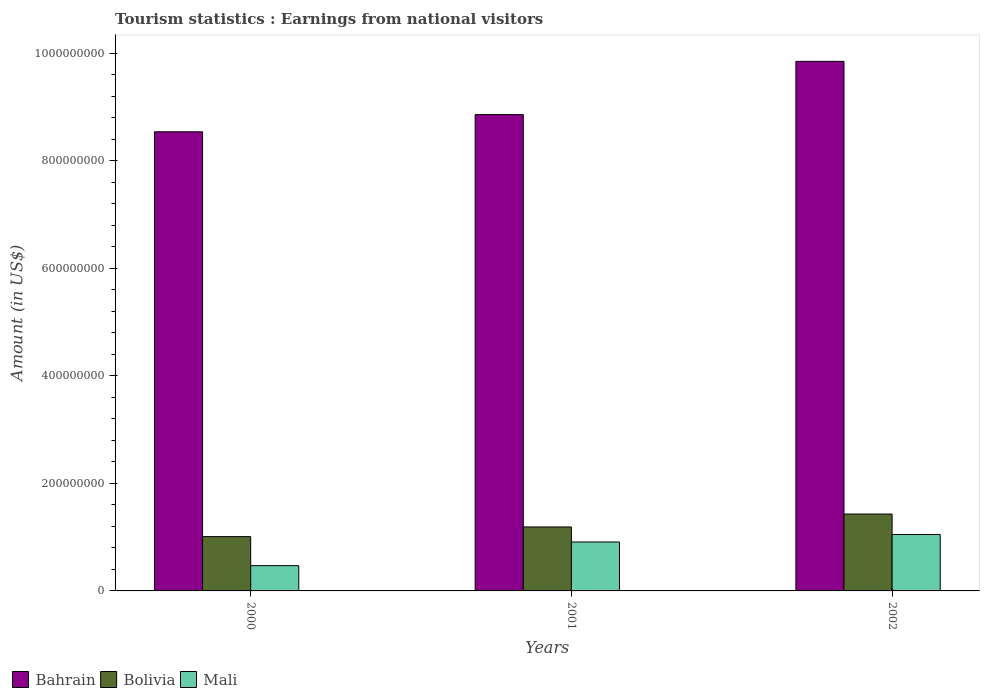How many different coloured bars are there?
Provide a short and direct response. 3. How many groups of bars are there?
Your response must be concise. 3. Are the number of bars per tick equal to the number of legend labels?
Keep it short and to the point. Yes. Are the number of bars on each tick of the X-axis equal?
Your response must be concise. Yes. What is the label of the 2nd group of bars from the left?
Make the answer very short. 2001. What is the earnings from national visitors in Bahrain in 2002?
Provide a succinct answer. 9.85e+08. Across all years, what is the maximum earnings from national visitors in Bolivia?
Your answer should be compact. 1.43e+08. Across all years, what is the minimum earnings from national visitors in Bahrain?
Your answer should be very brief. 8.54e+08. What is the total earnings from national visitors in Bahrain in the graph?
Your answer should be very brief. 2.72e+09. What is the difference between the earnings from national visitors in Mali in 2001 and that in 2002?
Provide a succinct answer. -1.40e+07. What is the difference between the earnings from national visitors in Bahrain in 2001 and the earnings from national visitors in Bolivia in 2002?
Make the answer very short. 7.43e+08. What is the average earnings from national visitors in Mali per year?
Your answer should be very brief. 8.10e+07. In the year 2002, what is the difference between the earnings from national visitors in Bahrain and earnings from national visitors in Mali?
Give a very brief answer. 8.80e+08. In how many years, is the earnings from national visitors in Bahrain greater than 640000000 US$?
Make the answer very short. 3. What is the ratio of the earnings from national visitors in Bolivia in 2001 to that in 2002?
Your answer should be compact. 0.83. Is the earnings from national visitors in Bolivia in 2000 less than that in 2002?
Give a very brief answer. Yes. Is the difference between the earnings from national visitors in Bahrain in 2000 and 2001 greater than the difference between the earnings from national visitors in Mali in 2000 and 2001?
Keep it short and to the point. Yes. What is the difference between the highest and the second highest earnings from national visitors in Mali?
Keep it short and to the point. 1.40e+07. What is the difference between the highest and the lowest earnings from national visitors in Bolivia?
Keep it short and to the point. 4.20e+07. Is the sum of the earnings from national visitors in Mali in 2001 and 2002 greater than the maximum earnings from national visitors in Bahrain across all years?
Your answer should be compact. No. What does the 3rd bar from the right in 2001 represents?
Make the answer very short. Bahrain. Are all the bars in the graph horizontal?
Give a very brief answer. No. How many years are there in the graph?
Ensure brevity in your answer.  3. What is the difference between two consecutive major ticks on the Y-axis?
Offer a terse response. 2.00e+08. Are the values on the major ticks of Y-axis written in scientific E-notation?
Offer a very short reply. No. Does the graph contain grids?
Your answer should be very brief. No. Where does the legend appear in the graph?
Make the answer very short. Bottom left. How many legend labels are there?
Make the answer very short. 3. How are the legend labels stacked?
Provide a succinct answer. Horizontal. What is the title of the graph?
Your response must be concise. Tourism statistics : Earnings from national visitors. Does "Guinea-Bissau" appear as one of the legend labels in the graph?
Offer a terse response. No. What is the label or title of the X-axis?
Your response must be concise. Years. What is the Amount (in US$) of Bahrain in 2000?
Ensure brevity in your answer.  8.54e+08. What is the Amount (in US$) of Bolivia in 2000?
Offer a very short reply. 1.01e+08. What is the Amount (in US$) of Mali in 2000?
Offer a terse response. 4.70e+07. What is the Amount (in US$) of Bahrain in 2001?
Provide a short and direct response. 8.86e+08. What is the Amount (in US$) in Bolivia in 2001?
Give a very brief answer. 1.19e+08. What is the Amount (in US$) in Mali in 2001?
Provide a succinct answer. 9.10e+07. What is the Amount (in US$) of Bahrain in 2002?
Provide a succinct answer. 9.85e+08. What is the Amount (in US$) of Bolivia in 2002?
Provide a short and direct response. 1.43e+08. What is the Amount (in US$) of Mali in 2002?
Keep it short and to the point. 1.05e+08. Across all years, what is the maximum Amount (in US$) in Bahrain?
Offer a very short reply. 9.85e+08. Across all years, what is the maximum Amount (in US$) in Bolivia?
Provide a short and direct response. 1.43e+08. Across all years, what is the maximum Amount (in US$) in Mali?
Your response must be concise. 1.05e+08. Across all years, what is the minimum Amount (in US$) in Bahrain?
Keep it short and to the point. 8.54e+08. Across all years, what is the minimum Amount (in US$) of Bolivia?
Make the answer very short. 1.01e+08. Across all years, what is the minimum Amount (in US$) in Mali?
Make the answer very short. 4.70e+07. What is the total Amount (in US$) in Bahrain in the graph?
Offer a very short reply. 2.72e+09. What is the total Amount (in US$) in Bolivia in the graph?
Ensure brevity in your answer.  3.63e+08. What is the total Amount (in US$) of Mali in the graph?
Provide a short and direct response. 2.43e+08. What is the difference between the Amount (in US$) of Bahrain in 2000 and that in 2001?
Make the answer very short. -3.20e+07. What is the difference between the Amount (in US$) in Bolivia in 2000 and that in 2001?
Provide a succinct answer. -1.80e+07. What is the difference between the Amount (in US$) of Mali in 2000 and that in 2001?
Your answer should be compact. -4.40e+07. What is the difference between the Amount (in US$) in Bahrain in 2000 and that in 2002?
Your response must be concise. -1.31e+08. What is the difference between the Amount (in US$) in Bolivia in 2000 and that in 2002?
Make the answer very short. -4.20e+07. What is the difference between the Amount (in US$) of Mali in 2000 and that in 2002?
Offer a terse response. -5.80e+07. What is the difference between the Amount (in US$) in Bahrain in 2001 and that in 2002?
Your response must be concise. -9.90e+07. What is the difference between the Amount (in US$) of Bolivia in 2001 and that in 2002?
Provide a succinct answer. -2.40e+07. What is the difference between the Amount (in US$) in Mali in 2001 and that in 2002?
Offer a terse response. -1.40e+07. What is the difference between the Amount (in US$) in Bahrain in 2000 and the Amount (in US$) in Bolivia in 2001?
Your answer should be compact. 7.35e+08. What is the difference between the Amount (in US$) in Bahrain in 2000 and the Amount (in US$) in Mali in 2001?
Your answer should be very brief. 7.63e+08. What is the difference between the Amount (in US$) of Bahrain in 2000 and the Amount (in US$) of Bolivia in 2002?
Offer a terse response. 7.11e+08. What is the difference between the Amount (in US$) of Bahrain in 2000 and the Amount (in US$) of Mali in 2002?
Your answer should be compact. 7.49e+08. What is the difference between the Amount (in US$) of Bolivia in 2000 and the Amount (in US$) of Mali in 2002?
Ensure brevity in your answer.  -4.00e+06. What is the difference between the Amount (in US$) in Bahrain in 2001 and the Amount (in US$) in Bolivia in 2002?
Your response must be concise. 7.43e+08. What is the difference between the Amount (in US$) of Bahrain in 2001 and the Amount (in US$) of Mali in 2002?
Make the answer very short. 7.81e+08. What is the difference between the Amount (in US$) of Bolivia in 2001 and the Amount (in US$) of Mali in 2002?
Your answer should be compact. 1.40e+07. What is the average Amount (in US$) in Bahrain per year?
Keep it short and to the point. 9.08e+08. What is the average Amount (in US$) in Bolivia per year?
Your answer should be compact. 1.21e+08. What is the average Amount (in US$) in Mali per year?
Offer a terse response. 8.10e+07. In the year 2000, what is the difference between the Amount (in US$) in Bahrain and Amount (in US$) in Bolivia?
Offer a very short reply. 7.53e+08. In the year 2000, what is the difference between the Amount (in US$) of Bahrain and Amount (in US$) of Mali?
Offer a terse response. 8.07e+08. In the year 2000, what is the difference between the Amount (in US$) of Bolivia and Amount (in US$) of Mali?
Give a very brief answer. 5.40e+07. In the year 2001, what is the difference between the Amount (in US$) of Bahrain and Amount (in US$) of Bolivia?
Provide a short and direct response. 7.67e+08. In the year 2001, what is the difference between the Amount (in US$) of Bahrain and Amount (in US$) of Mali?
Offer a terse response. 7.95e+08. In the year 2001, what is the difference between the Amount (in US$) in Bolivia and Amount (in US$) in Mali?
Your answer should be compact. 2.80e+07. In the year 2002, what is the difference between the Amount (in US$) of Bahrain and Amount (in US$) of Bolivia?
Offer a terse response. 8.42e+08. In the year 2002, what is the difference between the Amount (in US$) of Bahrain and Amount (in US$) of Mali?
Your response must be concise. 8.80e+08. In the year 2002, what is the difference between the Amount (in US$) in Bolivia and Amount (in US$) in Mali?
Your response must be concise. 3.80e+07. What is the ratio of the Amount (in US$) in Bahrain in 2000 to that in 2001?
Offer a very short reply. 0.96. What is the ratio of the Amount (in US$) in Bolivia in 2000 to that in 2001?
Provide a short and direct response. 0.85. What is the ratio of the Amount (in US$) of Mali in 2000 to that in 2001?
Your response must be concise. 0.52. What is the ratio of the Amount (in US$) in Bahrain in 2000 to that in 2002?
Ensure brevity in your answer.  0.87. What is the ratio of the Amount (in US$) in Bolivia in 2000 to that in 2002?
Make the answer very short. 0.71. What is the ratio of the Amount (in US$) in Mali in 2000 to that in 2002?
Your answer should be very brief. 0.45. What is the ratio of the Amount (in US$) in Bahrain in 2001 to that in 2002?
Ensure brevity in your answer.  0.9. What is the ratio of the Amount (in US$) of Bolivia in 2001 to that in 2002?
Your answer should be compact. 0.83. What is the ratio of the Amount (in US$) in Mali in 2001 to that in 2002?
Give a very brief answer. 0.87. What is the difference between the highest and the second highest Amount (in US$) in Bahrain?
Keep it short and to the point. 9.90e+07. What is the difference between the highest and the second highest Amount (in US$) of Bolivia?
Provide a succinct answer. 2.40e+07. What is the difference between the highest and the second highest Amount (in US$) of Mali?
Your answer should be compact. 1.40e+07. What is the difference between the highest and the lowest Amount (in US$) of Bahrain?
Keep it short and to the point. 1.31e+08. What is the difference between the highest and the lowest Amount (in US$) in Bolivia?
Offer a very short reply. 4.20e+07. What is the difference between the highest and the lowest Amount (in US$) in Mali?
Your answer should be very brief. 5.80e+07. 